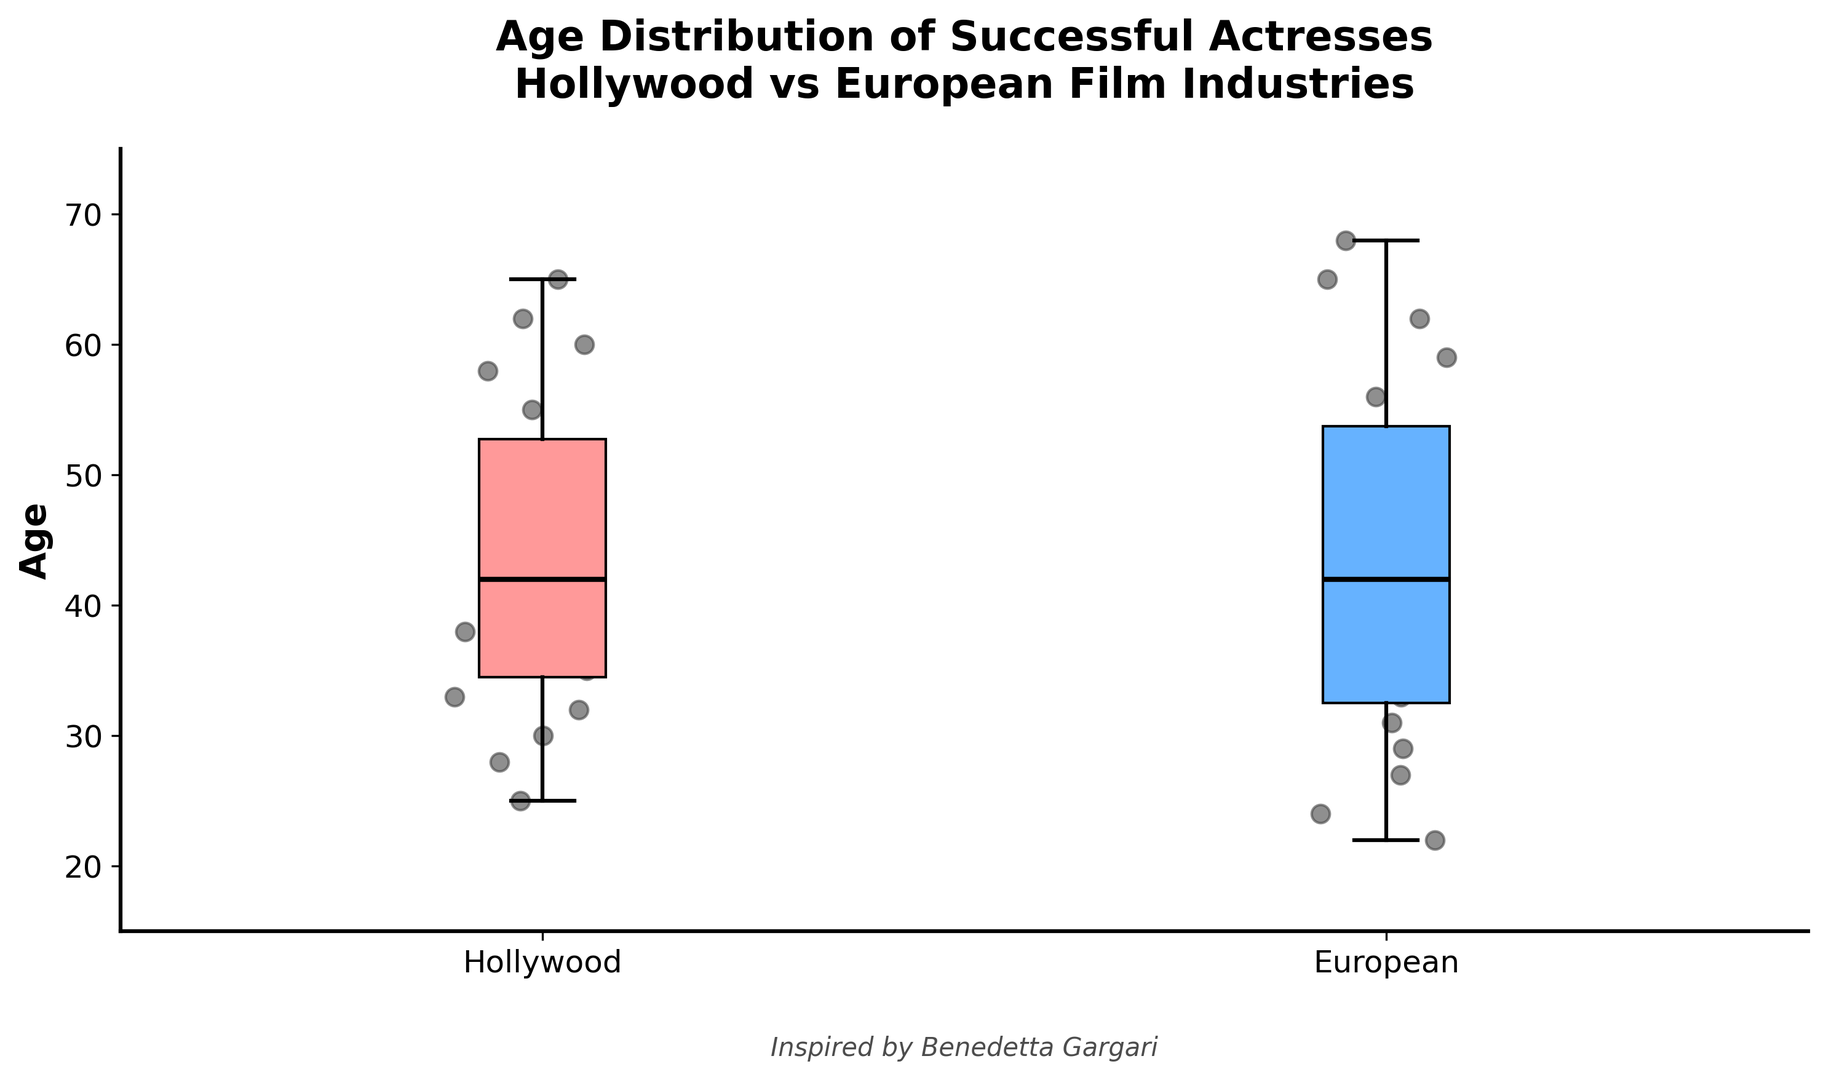What is the median age of successful actresses in Hollywood? By observing the box plot for Hollywood, the median is represented by the thick black line inside the box.
Answer: 41 What is the interquartile range (IQR) for European actresses? The IQR is found by subtracting the value at the 25th percentile (bottom edge of the box) from the value at the 75th percentile (top edge of the box). In the plot, these correspond to approximately 29 and 53, respectively. So, IQR = 53 - 29.
Answer: 24 How does the median age of European actresses compare to that of Hollywood actresses? The median age, indicated by the thick black line inside the box for each group, appears to be higher for European actresses than Hollywood actresses.
Answer: European actresses have a higher median age Which industry has a wider age distribution, and how can you tell? The range is wider for European actresses as seen by the length of the whiskers on each side of the boxplot, extending from about 22 to 68, compared to Hollywood's range of 25 to 65.
Answer: European What's the visual difference in the color of the boxes for each industry? The Hollywood box is filled with a light red color, and the European box is filled with a light blue color.
Answer: Hollywood is light red, European is light blue What is the upper whisker value for Hollywood actresses? The upper whisker extends to the maximum non-outlier value in the dataset, which for Hollywood actresses is around 65.
Answer: 65 Find the difference between the highest age of European actresses and Hollywood actresses. The highest age for European actresses is around 68 and for Hollywood actresses is around 65. The difference is 68 - 65.
Answer: 3 By observing the spread of data points, which industry seems to have outliers? There are no obvious outliers extending beyond the whiskers in either industry's boxplot, suggesting no outliers.
Answer: Neither 